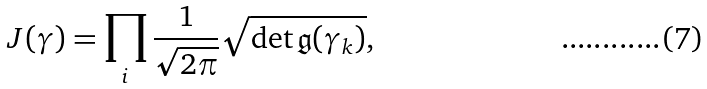Convert formula to latex. <formula><loc_0><loc_0><loc_500><loc_500>J ( \gamma ) = \prod _ { i } \frac { 1 } { \sqrt { 2 \pi } } \sqrt { \det \mathfrak { g } ( \gamma _ { k } ) } ,</formula> 